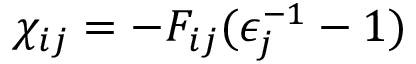<formula> <loc_0><loc_0><loc_500><loc_500>\chi _ { i j } = - F _ { i j } ( \epsilon _ { j } ^ { - 1 } - 1 )</formula> 